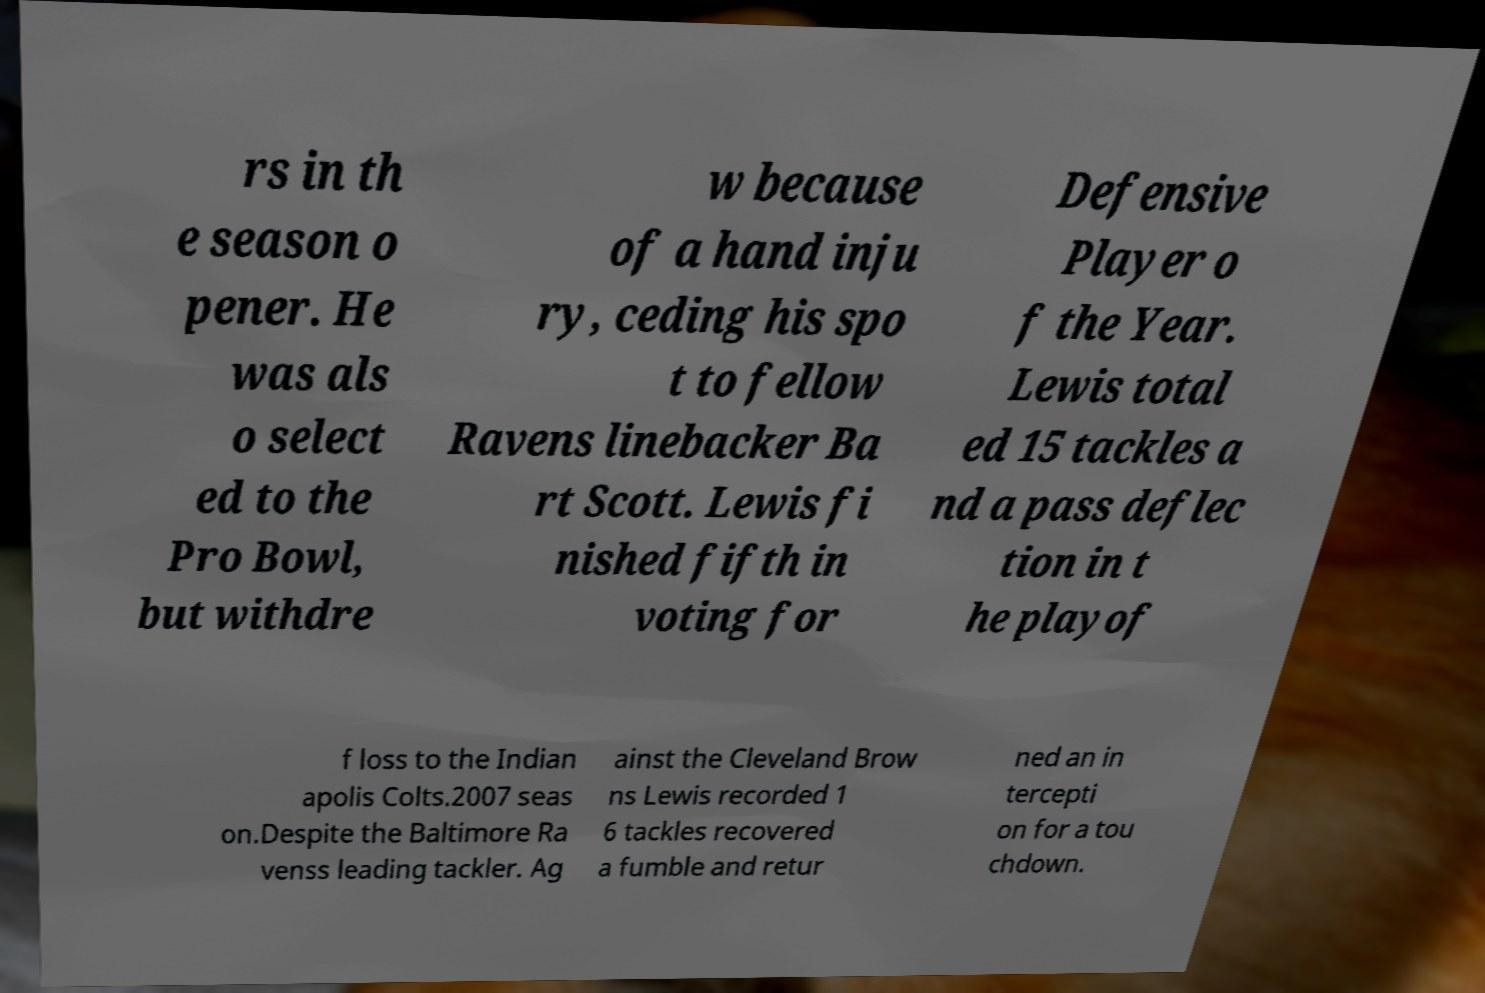Can you read and provide the text displayed in the image?This photo seems to have some interesting text. Can you extract and type it out for me? rs in th e season o pener. He was als o select ed to the Pro Bowl, but withdre w because of a hand inju ry, ceding his spo t to fellow Ravens linebacker Ba rt Scott. Lewis fi nished fifth in voting for Defensive Player o f the Year. Lewis total ed 15 tackles a nd a pass deflec tion in t he playof f loss to the Indian apolis Colts.2007 seas on.Despite the Baltimore Ra venss leading tackler. Ag ainst the Cleveland Brow ns Lewis recorded 1 6 tackles recovered a fumble and retur ned an in tercepti on for a tou chdown. 